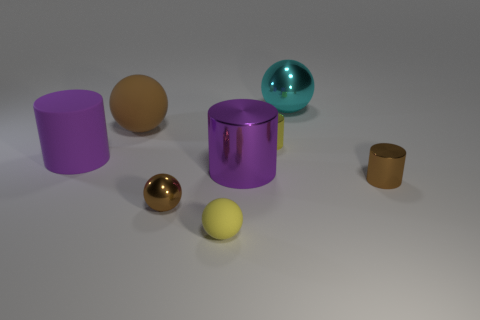Are there fewer tiny yellow things in front of the small matte thing than large purple shiny objects behind the large metallic cylinder?
Provide a succinct answer. No. What is the material of the large brown ball?
Offer a very short reply. Rubber. Do the large rubber cylinder and the shiny sphere to the left of the yellow rubber thing have the same color?
Offer a very short reply. No. There is a large rubber ball; how many small yellow balls are on the right side of it?
Offer a very short reply. 1. Is the number of tiny yellow metallic cylinders in front of the large metal cylinder less than the number of big red balls?
Provide a short and direct response. No. The big metal ball is what color?
Give a very brief answer. Cyan. Does the shiny thing behind the yellow metallic cylinder have the same color as the small metal ball?
Provide a short and direct response. No. There is a matte object that is the same shape as the big purple shiny object; what color is it?
Your answer should be compact. Purple. What number of large objects are cyan shiny balls or yellow matte spheres?
Make the answer very short. 1. There is a metal thing that is on the right side of the cyan ball; what size is it?
Keep it short and to the point. Small. 